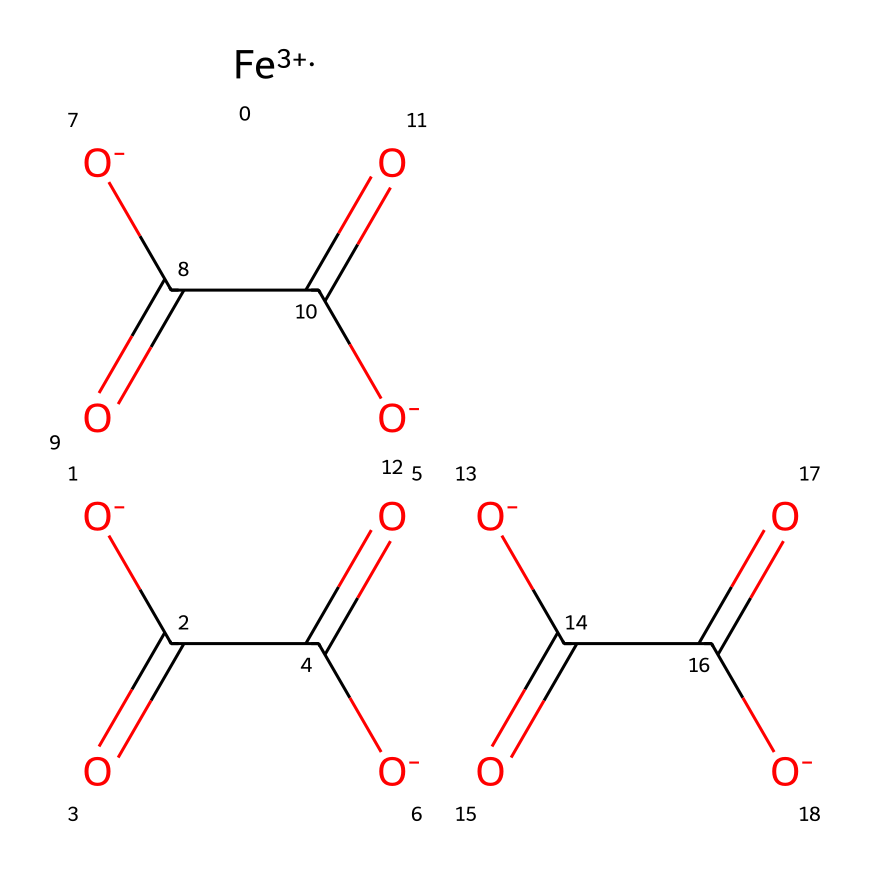What is the oxidation state of iron in this compound? The notation [Fe+3] indicates that the oxidation state of iron in this compound is +3.
Answer: +3 How many carboxylate groups are present in this compound? The chemical structure includes three sequences of [O-]C(=O)C(=O)[O-], each representing a carboxylate group, so there are three carboxylate groups in total.
Answer: 3 What type of bonding characterizes the bond between iron and the ligands? In coordination compounds, the bond between the central metal ion (iron) and the surrounding ligands (carboxylate groups) is coordinate covalent bonding, implying that the ligands donate electron pairs to the metal.
Answer: coordinate covalent What would be the main role of the carboxylate ligands in the soil? Carboxylate ligands can stabilize the iron ion in the soil and influence nutrient availability for plants through complexation.
Answer: stabilize How many total oxygen atoms are present in this chemical structure? Each carboxylate group contributes 2 oxygen atoms, and there are 3 such groups, yielding 6. Additionally, the single oxygen from [O-] in the ligands adds another 3, totaling 9 oxygen atoms.
Answer: 9 Does this coordination compound typically display solubility in water? Generally, coordination compounds involving carboxylate ligands, such as the one represented, tend to have good solubility in water due to their ionic nature.
Answer: yes 